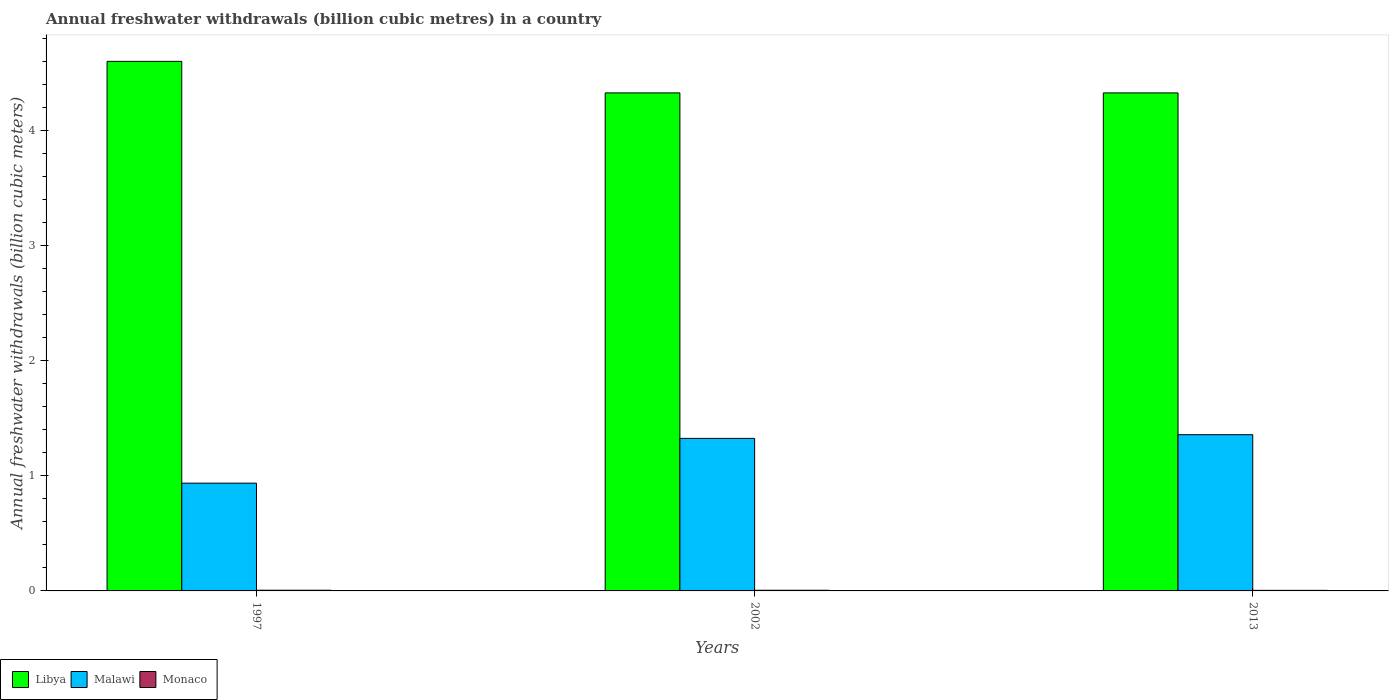How many groups of bars are there?
Ensure brevity in your answer.  3. Are the number of bars on each tick of the X-axis equal?
Your answer should be compact. Yes. How many bars are there on the 2nd tick from the left?
Offer a terse response. 3. What is the label of the 3rd group of bars from the left?
Your answer should be compact. 2013. In how many cases, is the number of bars for a given year not equal to the number of legend labels?
Ensure brevity in your answer.  0. What is the annual freshwater withdrawals in Monaco in 2002?
Provide a succinct answer. 0.01. Across all years, what is the maximum annual freshwater withdrawals in Malawi?
Keep it short and to the point. 1.36. Across all years, what is the minimum annual freshwater withdrawals in Malawi?
Offer a very short reply. 0.94. In which year was the annual freshwater withdrawals in Libya minimum?
Give a very brief answer. 2002. What is the total annual freshwater withdrawals in Monaco in the graph?
Offer a terse response. 0.02. What is the difference between the annual freshwater withdrawals in Malawi in 1997 and that in 2013?
Provide a short and direct response. -0.42. What is the difference between the annual freshwater withdrawals in Libya in 1997 and the annual freshwater withdrawals in Monaco in 2002?
Ensure brevity in your answer.  4.59. What is the average annual freshwater withdrawals in Libya per year?
Make the answer very short. 4.42. In the year 1997, what is the difference between the annual freshwater withdrawals in Malawi and annual freshwater withdrawals in Libya?
Make the answer very short. -3.66. What is the ratio of the annual freshwater withdrawals in Libya in 1997 to that in 2013?
Ensure brevity in your answer.  1.06. Is the difference between the annual freshwater withdrawals in Malawi in 1997 and 2002 greater than the difference between the annual freshwater withdrawals in Libya in 1997 and 2002?
Offer a terse response. No. What is the difference between the highest and the second highest annual freshwater withdrawals in Monaco?
Provide a succinct answer. 0. What is the difference between the highest and the lowest annual freshwater withdrawals in Monaco?
Provide a short and direct response. 0. In how many years, is the annual freshwater withdrawals in Malawi greater than the average annual freshwater withdrawals in Malawi taken over all years?
Your response must be concise. 2. Is the sum of the annual freshwater withdrawals in Malawi in 1997 and 2013 greater than the maximum annual freshwater withdrawals in Libya across all years?
Provide a succinct answer. No. What does the 1st bar from the left in 2002 represents?
Give a very brief answer. Libya. What does the 1st bar from the right in 2002 represents?
Offer a terse response. Monaco. Is it the case that in every year, the sum of the annual freshwater withdrawals in Monaco and annual freshwater withdrawals in Malawi is greater than the annual freshwater withdrawals in Libya?
Provide a succinct answer. No. What is the difference between two consecutive major ticks on the Y-axis?
Your response must be concise. 1. Are the values on the major ticks of Y-axis written in scientific E-notation?
Provide a succinct answer. No. Where does the legend appear in the graph?
Ensure brevity in your answer.  Bottom left. How are the legend labels stacked?
Provide a short and direct response. Horizontal. What is the title of the graph?
Make the answer very short. Annual freshwater withdrawals (billion cubic metres) in a country. Does "Jordan" appear as one of the legend labels in the graph?
Your response must be concise. No. What is the label or title of the X-axis?
Offer a very short reply. Years. What is the label or title of the Y-axis?
Offer a very short reply. Annual freshwater withdrawals (billion cubic meters). What is the Annual freshwater withdrawals (billion cubic meters) of Libya in 1997?
Provide a short and direct response. 4.6. What is the Annual freshwater withdrawals (billion cubic meters) in Malawi in 1997?
Your answer should be compact. 0.94. What is the Annual freshwater withdrawals (billion cubic meters) in Monaco in 1997?
Make the answer very short. 0.01. What is the Annual freshwater withdrawals (billion cubic meters) in Libya in 2002?
Provide a short and direct response. 4.33. What is the Annual freshwater withdrawals (billion cubic meters) in Malawi in 2002?
Offer a very short reply. 1.32. What is the Annual freshwater withdrawals (billion cubic meters) of Monaco in 2002?
Provide a succinct answer. 0.01. What is the Annual freshwater withdrawals (billion cubic meters) in Libya in 2013?
Give a very brief answer. 4.33. What is the Annual freshwater withdrawals (billion cubic meters) of Malawi in 2013?
Ensure brevity in your answer.  1.36. What is the Annual freshwater withdrawals (billion cubic meters) of Monaco in 2013?
Provide a succinct answer. 0.01. Across all years, what is the maximum Annual freshwater withdrawals (billion cubic meters) in Malawi?
Your answer should be compact. 1.36. Across all years, what is the maximum Annual freshwater withdrawals (billion cubic meters) in Monaco?
Provide a succinct answer. 0.01. Across all years, what is the minimum Annual freshwater withdrawals (billion cubic meters) of Libya?
Offer a very short reply. 4.33. Across all years, what is the minimum Annual freshwater withdrawals (billion cubic meters) in Malawi?
Offer a terse response. 0.94. Across all years, what is the minimum Annual freshwater withdrawals (billion cubic meters) of Monaco?
Keep it short and to the point. 0.01. What is the total Annual freshwater withdrawals (billion cubic meters) of Libya in the graph?
Offer a terse response. 13.25. What is the total Annual freshwater withdrawals (billion cubic meters) in Malawi in the graph?
Provide a short and direct response. 3.62. What is the total Annual freshwater withdrawals (billion cubic meters) of Monaco in the graph?
Your answer should be very brief. 0.02. What is the difference between the Annual freshwater withdrawals (billion cubic meters) of Libya in 1997 and that in 2002?
Your answer should be compact. 0.27. What is the difference between the Annual freshwater withdrawals (billion cubic meters) in Malawi in 1997 and that in 2002?
Provide a short and direct response. -0.39. What is the difference between the Annual freshwater withdrawals (billion cubic meters) in Libya in 1997 and that in 2013?
Your response must be concise. 0.27. What is the difference between the Annual freshwater withdrawals (billion cubic meters) of Malawi in 1997 and that in 2013?
Your response must be concise. -0.42. What is the difference between the Annual freshwater withdrawals (billion cubic meters) in Libya in 2002 and that in 2013?
Ensure brevity in your answer.  0. What is the difference between the Annual freshwater withdrawals (billion cubic meters) of Malawi in 2002 and that in 2013?
Offer a very short reply. -0.03. What is the difference between the Annual freshwater withdrawals (billion cubic meters) in Monaco in 2002 and that in 2013?
Make the answer very short. 0. What is the difference between the Annual freshwater withdrawals (billion cubic meters) in Libya in 1997 and the Annual freshwater withdrawals (billion cubic meters) in Malawi in 2002?
Make the answer very short. 3.27. What is the difference between the Annual freshwater withdrawals (billion cubic meters) in Libya in 1997 and the Annual freshwater withdrawals (billion cubic meters) in Monaco in 2002?
Provide a succinct answer. 4.59. What is the difference between the Annual freshwater withdrawals (billion cubic meters) in Malawi in 1997 and the Annual freshwater withdrawals (billion cubic meters) in Monaco in 2002?
Offer a very short reply. 0.93. What is the difference between the Annual freshwater withdrawals (billion cubic meters) of Libya in 1997 and the Annual freshwater withdrawals (billion cubic meters) of Malawi in 2013?
Provide a short and direct response. 3.24. What is the difference between the Annual freshwater withdrawals (billion cubic meters) of Libya in 1997 and the Annual freshwater withdrawals (billion cubic meters) of Monaco in 2013?
Make the answer very short. 4.59. What is the difference between the Annual freshwater withdrawals (billion cubic meters) in Malawi in 1997 and the Annual freshwater withdrawals (billion cubic meters) in Monaco in 2013?
Offer a terse response. 0.93. What is the difference between the Annual freshwater withdrawals (billion cubic meters) of Libya in 2002 and the Annual freshwater withdrawals (billion cubic meters) of Malawi in 2013?
Offer a very short reply. 2.97. What is the difference between the Annual freshwater withdrawals (billion cubic meters) of Libya in 2002 and the Annual freshwater withdrawals (billion cubic meters) of Monaco in 2013?
Provide a succinct answer. 4.32. What is the difference between the Annual freshwater withdrawals (billion cubic meters) in Malawi in 2002 and the Annual freshwater withdrawals (billion cubic meters) in Monaco in 2013?
Make the answer very short. 1.32. What is the average Annual freshwater withdrawals (billion cubic meters) in Libya per year?
Your answer should be compact. 4.42. What is the average Annual freshwater withdrawals (billion cubic meters) of Malawi per year?
Keep it short and to the point. 1.21. What is the average Annual freshwater withdrawals (billion cubic meters) in Monaco per year?
Your answer should be very brief. 0.01. In the year 1997, what is the difference between the Annual freshwater withdrawals (billion cubic meters) of Libya and Annual freshwater withdrawals (billion cubic meters) of Malawi?
Provide a succinct answer. 3.66. In the year 1997, what is the difference between the Annual freshwater withdrawals (billion cubic meters) of Libya and Annual freshwater withdrawals (billion cubic meters) of Monaco?
Provide a short and direct response. 4.59. In the year 1997, what is the difference between the Annual freshwater withdrawals (billion cubic meters) in Malawi and Annual freshwater withdrawals (billion cubic meters) in Monaco?
Ensure brevity in your answer.  0.93. In the year 2002, what is the difference between the Annual freshwater withdrawals (billion cubic meters) in Libya and Annual freshwater withdrawals (billion cubic meters) in Malawi?
Your answer should be compact. 3. In the year 2002, what is the difference between the Annual freshwater withdrawals (billion cubic meters) of Libya and Annual freshwater withdrawals (billion cubic meters) of Monaco?
Your answer should be very brief. 4.32. In the year 2002, what is the difference between the Annual freshwater withdrawals (billion cubic meters) of Malawi and Annual freshwater withdrawals (billion cubic meters) of Monaco?
Provide a short and direct response. 1.32. In the year 2013, what is the difference between the Annual freshwater withdrawals (billion cubic meters) in Libya and Annual freshwater withdrawals (billion cubic meters) in Malawi?
Your answer should be compact. 2.97. In the year 2013, what is the difference between the Annual freshwater withdrawals (billion cubic meters) in Libya and Annual freshwater withdrawals (billion cubic meters) in Monaco?
Your response must be concise. 4.32. In the year 2013, what is the difference between the Annual freshwater withdrawals (billion cubic meters) in Malawi and Annual freshwater withdrawals (billion cubic meters) in Monaco?
Your answer should be very brief. 1.35. What is the ratio of the Annual freshwater withdrawals (billion cubic meters) in Libya in 1997 to that in 2002?
Provide a short and direct response. 1.06. What is the ratio of the Annual freshwater withdrawals (billion cubic meters) in Malawi in 1997 to that in 2002?
Ensure brevity in your answer.  0.71. What is the ratio of the Annual freshwater withdrawals (billion cubic meters) in Monaco in 1997 to that in 2002?
Keep it short and to the point. 1.03. What is the ratio of the Annual freshwater withdrawals (billion cubic meters) of Libya in 1997 to that in 2013?
Provide a succinct answer. 1.06. What is the ratio of the Annual freshwater withdrawals (billion cubic meters) in Malawi in 1997 to that in 2013?
Offer a very short reply. 0.69. What is the ratio of the Annual freshwater withdrawals (billion cubic meters) of Monaco in 1997 to that in 2013?
Make the answer very short. 1.2. What is the ratio of the Annual freshwater withdrawals (billion cubic meters) of Malawi in 2002 to that in 2013?
Make the answer very short. 0.98. What is the ratio of the Annual freshwater withdrawals (billion cubic meters) in Monaco in 2002 to that in 2013?
Give a very brief answer. 1.16. What is the difference between the highest and the second highest Annual freshwater withdrawals (billion cubic meters) of Libya?
Offer a very short reply. 0.27. What is the difference between the highest and the second highest Annual freshwater withdrawals (billion cubic meters) in Malawi?
Provide a succinct answer. 0.03. What is the difference between the highest and the second highest Annual freshwater withdrawals (billion cubic meters) of Monaco?
Give a very brief answer. 0. What is the difference between the highest and the lowest Annual freshwater withdrawals (billion cubic meters) in Libya?
Give a very brief answer. 0.27. What is the difference between the highest and the lowest Annual freshwater withdrawals (billion cubic meters) in Malawi?
Your answer should be very brief. 0.42. What is the difference between the highest and the lowest Annual freshwater withdrawals (billion cubic meters) of Monaco?
Make the answer very short. 0. 